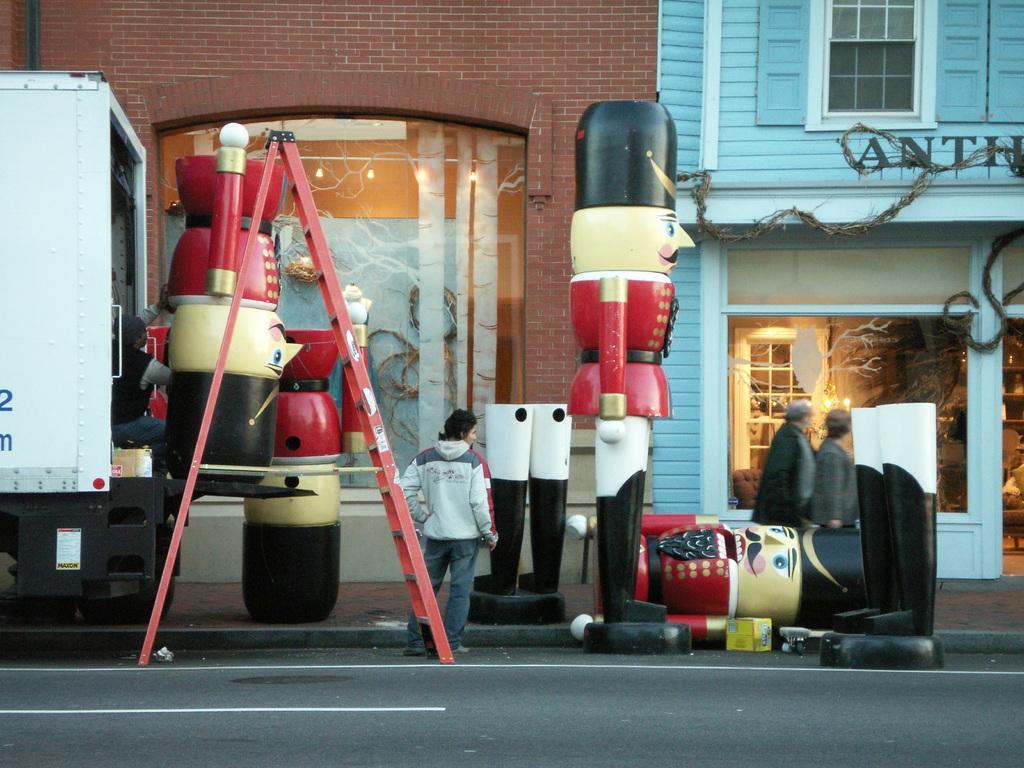How would you summarize this image in a sentence or two? In this image I can see the road. To the side of the road I can see the toys and few people with different color dresses. I can see the iron rod and the vehicle to the left. In the background I can see the buildings with windows. 